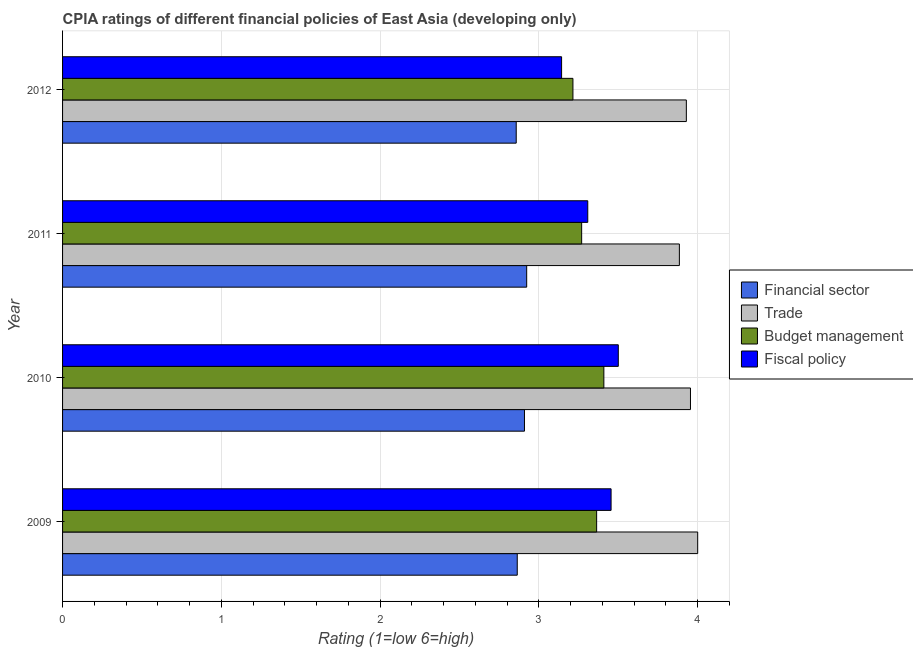How many different coloured bars are there?
Offer a very short reply. 4. Are the number of bars per tick equal to the number of legend labels?
Your response must be concise. Yes. Are the number of bars on each tick of the Y-axis equal?
Your answer should be very brief. Yes. How many bars are there on the 1st tick from the top?
Your answer should be very brief. 4. How many bars are there on the 2nd tick from the bottom?
Your answer should be compact. 4. Across all years, what is the maximum cpia rating of fiscal policy?
Give a very brief answer. 3.5. Across all years, what is the minimum cpia rating of fiscal policy?
Keep it short and to the point. 3.14. In which year was the cpia rating of budget management maximum?
Your answer should be very brief. 2010. What is the total cpia rating of fiscal policy in the graph?
Your answer should be very brief. 13.41. What is the difference between the cpia rating of financial sector in 2010 and that in 2012?
Provide a short and direct response. 0.05. What is the difference between the cpia rating of financial sector in 2009 and the cpia rating of fiscal policy in 2010?
Your answer should be very brief. -0.64. What is the average cpia rating of budget management per year?
Your answer should be very brief. 3.31. In the year 2009, what is the difference between the cpia rating of fiscal policy and cpia rating of budget management?
Your answer should be very brief. 0.09. In how many years, is the cpia rating of budget management greater than 3.6 ?
Your answer should be very brief. 0. What is the ratio of the cpia rating of financial sector in 2010 to that in 2011?
Give a very brief answer. 0.99. What is the difference between the highest and the second highest cpia rating of financial sector?
Provide a succinct answer. 0.01. What is the difference between the highest and the lowest cpia rating of budget management?
Keep it short and to the point. 0.19. Is the sum of the cpia rating of fiscal policy in 2009 and 2010 greater than the maximum cpia rating of financial sector across all years?
Make the answer very short. Yes. What does the 4th bar from the top in 2011 represents?
Provide a succinct answer. Financial sector. What does the 4th bar from the bottom in 2009 represents?
Give a very brief answer. Fiscal policy. How many bars are there?
Make the answer very short. 16. Are all the bars in the graph horizontal?
Offer a very short reply. Yes. How many years are there in the graph?
Your answer should be compact. 4. What is the difference between two consecutive major ticks on the X-axis?
Your answer should be compact. 1. Where does the legend appear in the graph?
Your answer should be very brief. Center right. What is the title of the graph?
Keep it short and to the point. CPIA ratings of different financial policies of East Asia (developing only). What is the label or title of the X-axis?
Your answer should be very brief. Rating (1=low 6=high). What is the Rating (1=low 6=high) in Financial sector in 2009?
Your answer should be very brief. 2.86. What is the Rating (1=low 6=high) in Budget management in 2009?
Provide a succinct answer. 3.36. What is the Rating (1=low 6=high) of Fiscal policy in 2009?
Make the answer very short. 3.45. What is the Rating (1=low 6=high) in Financial sector in 2010?
Offer a very short reply. 2.91. What is the Rating (1=low 6=high) of Trade in 2010?
Ensure brevity in your answer.  3.95. What is the Rating (1=low 6=high) of Budget management in 2010?
Offer a terse response. 3.41. What is the Rating (1=low 6=high) in Fiscal policy in 2010?
Provide a short and direct response. 3.5. What is the Rating (1=low 6=high) in Financial sector in 2011?
Provide a succinct answer. 2.92. What is the Rating (1=low 6=high) of Trade in 2011?
Ensure brevity in your answer.  3.88. What is the Rating (1=low 6=high) of Budget management in 2011?
Ensure brevity in your answer.  3.27. What is the Rating (1=low 6=high) in Fiscal policy in 2011?
Give a very brief answer. 3.31. What is the Rating (1=low 6=high) of Financial sector in 2012?
Your response must be concise. 2.86. What is the Rating (1=low 6=high) of Trade in 2012?
Make the answer very short. 3.93. What is the Rating (1=low 6=high) of Budget management in 2012?
Provide a short and direct response. 3.21. What is the Rating (1=low 6=high) in Fiscal policy in 2012?
Provide a short and direct response. 3.14. Across all years, what is the maximum Rating (1=low 6=high) of Financial sector?
Your answer should be compact. 2.92. Across all years, what is the maximum Rating (1=low 6=high) in Trade?
Offer a very short reply. 4. Across all years, what is the maximum Rating (1=low 6=high) of Budget management?
Your answer should be very brief. 3.41. Across all years, what is the maximum Rating (1=low 6=high) of Fiscal policy?
Offer a terse response. 3.5. Across all years, what is the minimum Rating (1=low 6=high) of Financial sector?
Your response must be concise. 2.86. Across all years, what is the minimum Rating (1=low 6=high) in Trade?
Provide a succinct answer. 3.88. Across all years, what is the minimum Rating (1=low 6=high) of Budget management?
Your response must be concise. 3.21. Across all years, what is the minimum Rating (1=low 6=high) of Fiscal policy?
Provide a short and direct response. 3.14. What is the total Rating (1=low 6=high) of Financial sector in the graph?
Make the answer very short. 11.55. What is the total Rating (1=low 6=high) of Trade in the graph?
Your response must be concise. 15.77. What is the total Rating (1=low 6=high) of Budget management in the graph?
Keep it short and to the point. 13.26. What is the total Rating (1=low 6=high) of Fiscal policy in the graph?
Make the answer very short. 13.41. What is the difference between the Rating (1=low 6=high) of Financial sector in 2009 and that in 2010?
Give a very brief answer. -0.05. What is the difference between the Rating (1=low 6=high) of Trade in 2009 and that in 2010?
Offer a terse response. 0.05. What is the difference between the Rating (1=low 6=high) in Budget management in 2009 and that in 2010?
Provide a short and direct response. -0.05. What is the difference between the Rating (1=low 6=high) in Fiscal policy in 2009 and that in 2010?
Your answer should be very brief. -0.05. What is the difference between the Rating (1=low 6=high) in Financial sector in 2009 and that in 2011?
Offer a very short reply. -0.06. What is the difference between the Rating (1=low 6=high) in Trade in 2009 and that in 2011?
Your response must be concise. 0.12. What is the difference between the Rating (1=low 6=high) in Budget management in 2009 and that in 2011?
Provide a short and direct response. 0.09. What is the difference between the Rating (1=low 6=high) in Fiscal policy in 2009 and that in 2011?
Your response must be concise. 0.15. What is the difference between the Rating (1=low 6=high) in Financial sector in 2009 and that in 2012?
Your answer should be very brief. 0.01. What is the difference between the Rating (1=low 6=high) in Trade in 2009 and that in 2012?
Ensure brevity in your answer.  0.07. What is the difference between the Rating (1=low 6=high) of Budget management in 2009 and that in 2012?
Your answer should be compact. 0.15. What is the difference between the Rating (1=low 6=high) of Fiscal policy in 2009 and that in 2012?
Your response must be concise. 0.31. What is the difference between the Rating (1=low 6=high) of Financial sector in 2010 and that in 2011?
Offer a terse response. -0.01. What is the difference between the Rating (1=low 6=high) in Trade in 2010 and that in 2011?
Ensure brevity in your answer.  0.07. What is the difference between the Rating (1=low 6=high) in Budget management in 2010 and that in 2011?
Ensure brevity in your answer.  0.14. What is the difference between the Rating (1=low 6=high) in Fiscal policy in 2010 and that in 2011?
Ensure brevity in your answer.  0.19. What is the difference between the Rating (1=low 6=high) of Financial sector in 2010 and that in 2012?
Offer a terse response. 0.05. What is the difference between the Rating (1=low 6=high) of Trade in 2010 and that in 2012?
Provide a short and direct response. 0.03. What is the difference between the Rating (1=low 6=high) in Budget management in 2010 and that in 2012?
Provide a succinct answer. 0.19. What is the difference between the Rating (1=low 6=high) in Fiscal policy in 2010 and that in 2012?
Offer a terse response. 0.36. What is the difference between the Rating (1=low 6=high) of Financial sector in 2011 and that in 2012?
Your response must be concise. 0.07. What is the difference between the Rating (1=low 6=high) of Trade in 2011 and that in 2012?
Offer a terse response. -0.04. What is the difference between the Rating (1=low 6=high) in Budget management in 2011 and that in 2012?
Offer a terse response. 0.05. What is the difference between the Rating (1=low 6=high) of Fiscal policy in 2011 and that in 2012?
Give a very brief answer. 0.16. What is the difference between the Rating (1=low 6=high) in Financial sector in 2009 and the Rating (1=low 6=high) in Trade in 2010?
Your response must be concise. -1.09. What is the difference between the Rating (1=low 6=high) of Financial sector in 2009 and the Rating (1=low 6=high) of Budget management in 2010?
Your answer should be compact. -0.55. What is the difference between the Rating (1=low 6=high) in Financial sector in 2009 and the Rating (1=low 6=high) in Fiscal policy in 2010?
Make the answer very short. -0.64. What is the difference between the Rating (1=low 6=high) of Trade in 2009 and the Rating (1=low 6=high) of Budget management in 2010?
Provide a succinct answer. 0.59. What is the difference between the Rating (1=low 6=high) of Trade in 2009 and the Rating (1=low 6=high) of Fiscal policy in 2010?
Ensure brevity in your answer.  0.5. What is the difference between the Rating (1=low 6=high) of Budget management in 2009 and the Rating (1=low 6=high) of Fiscal policy in 2010?
Offer a terse response. -0.14. What is the difference between the Rating (1=low 6=high) in Financial sector in 2009 and the Rating (1=low 6=high) in Trade in 2011?
Your answer should be very brief. -1.02. What is the difference between the Rating (1=low 6=high) of Financial sector in 2009 and the Rating (1=low 6=high) of Budget management in 2011?
Ensure brevity in your answer.  -0.41. What is the difference between the Rating (1=low 6=high) of Financial sector in 2009 and the Rating (1=low 6=high) of Fiscal policy in 2011?
Keep it short and to the point. -0.44. What is the difference between the Rating (1=low 6=high) in Trade in 2009 and the Rating (1=low 6=high) in Budget management in 2011?
Your answer should be compact. 0.73. What is the difference between the Rating (1=low 6=high) of Trade in 2009 and the Rating (1=low 6=high) of Fiscal policy in 2011?
Your answer should be compact. 0.69. What is the difference between the Rating (1=low 6=high) in Budget management in 2009 and the Rating (1=low 6=high) in Fiscal policy in 2011?
Your answer should be very brief. 0.06. What is the difference between the Rating (1=low 6=high) in Financial sector in 2009 and the Rating (1=low 6=high) in Trade in 2012?
Your response must be concise. -1.06. What is the difference between the Rating (1=low 6=high) in Financial sector in 2009 and the Rating (1=low 6=high) in Budget management in 2012?
Offer a terse response. -0.35. What is the difference between the Rating (1=low 6=high) in Financial sector in 2009 and the Rating (1=low 6=high) in Fiscal policy in 2012?
Keep it short and to the point. -0.28. What is the difference between the Rating (1=low 6=high) in Trade in 2009 and the Rating (1=low 6=high) in Budget management in 2012?
Provide a short and direct response. 0.79. What is the difference between the Rating (1=low 6=high) in Budget management in 2009 and the Rating (1=low 6=high) in Fiscal policy in 2012?
Provide a short and direct response. 0.22. What is the difference between the Rating (1=low 6=high) of Financial sector in 2010 and the Rating (1=low 6=high) of Trade in 2011?
Ensure brevity in your answer.  -0.98. What is the difference between the Rating (1=low 6=high) of Financial sector in 2010 and the Rating (1=low 6=high) of Budget management in 2011?
Provide a short and direct response. -0.36. What is the difference between the Rating (1=low 6=high) of Financial sector in 2010 and the Rating (1=low 6=high) of Fiscal policy in 2011?
Your answer should be very brief. -0.4. What is the difference between the Rating (1=low 6=high) in Trade in 2010 and the Rating (1=low 6=high) in Budget management in 2011?
Your answer should be very brief. 0.69. What is the difference between the Rating (1=low 6=high) in Trade in 2010 and the Rating (1=low 6=high) in Fiscal policy in 2011?
Provide a short and direct response. 0.65. What is the difference between the Rating (1=low 6=high) in Budget management in 2010 and the Rating (1=low 6=high) in Fiscal policy in 2011?
Ensure brevity in your answer.  0.1. What is the difference between the Rating (1=low 6=high) of Financial sector in 2010 and the Rating (1=low 6=high) of Trade in 2012?
Offer a terse response. -1.02. What is the difference between the Rating (1=low 6=high) of Financial sector in 2010 and the Rating (1=low 6=high) of Budget management in 2012?
Ensure brevity in your answer.  -0.31. What is the difference between the Rating (1=low 6=high) in Financial sector in 2010 and the Rating (1=low 6=high) in Fiscal policy in 2012?
Give a very brief answer. -0.23. What is the difference between the Rating (1=low 6=high) in Trade in 2010 and the Rating (1=low 6=high) in Budget management in 2012?
Make the answer very short. 0.74. What is the difference between the Rating (1=low 6=high) in Trade in 2010 and the Rating (1=low 6=high) in Fiscal policy in 2012?
Give a very brief answer. 0.81. What is the difference between the Rating (1=low 6=high) in Budget management in 2010 and the Rating (1=low 6=high) in Fiscal policy in 2012?
Offer a terse response. 0.27. What is the difference between the Rating (1=low 6=high) of Financial sector in 2011 and the Rating (1=low 6=high) of Trade in 2012?
Provide a short and direct response. -1.01. What is the difference between the Rating (1=low 6=high) of Financial sector in 2011 and the Rating (1=low 6=high) of Budget management in 2012?
Offer a very short reply. -0.29. What is the difference between the Rating (1=low 6=high) in Financial sector in 2011 and the Rating (1=low 6=high) in Fiscal policy in 2012?
Your answer should be very brief. -0.22. What is the difference between the Rating (1=low 6=high) of Trade in 2011 and the Rating (1=low 6=high) of Budget management in 2012?
Keep it short and to the point. 0.67. What is the difference between the Rating (1=low 6=high) in Trade in 2011 and the Rating (1=low 6=high) in Fiscal policy in 2012?
Provide a succinct answer. 0.74. What is the difference between the Rating (1=low 6=high) of Budget management in 2011 and the Rating (1=low 6=high) of Fiscal policy in 2012?
Your answer should be compact. 0.13. What is the average Rating (1=low 6=high) in Financial sector per year?
Keep it short and to the point. 2.89. What is the average Rating (1=low 6=high) of Trade per year?
Your answer should be very brief. 3.94. What is the average Rating (1=low 6=high) in Budget management per year?
Offer a very short reply. 3.31. What is the average Rating (1=low 6=high) of Fiscal policy per year?
Your response must be concise. 3.35. In the year 2009, what is the difference between the Rating (1=low 6=high) of Financial sector and Rating (1=low 6=high) of Trade?
Keep it short and to the point. -1.14. In the year 2009, what is the difference between the Rating (1=low 6=high) in Financial sector and Rating (1=low 6=high) in Fiscal policy?
Provide a short and direct response. -0.59. In the year 2009, what is the difference between the Rating (1=low 6=high) in Trade and Rating (1=low 6=high) in Budget management?
Offer a terse response. 0.64. In the year 2009, what is the difference between the Rating (1=low 6=high) in Trade and Rating (1=low 6=high) in Fiscal policy?
Make the answer very short. 0.55. In the year 2009, what is the difference between the Rating (1=low 6=high) of Budget management and Rating (1=low 6=high) of Fiscal policy?
Offer a very short reply. -0.09. In the year 2010, what is the difference between the Rating (1=low 6=high) in Financial sector and Rating (1=low 6=high) in Trade?
Your response must be concise. -1.05. In the year 2010, what is the difference between the Rating (1=low 6=high) in Financial sector and Rating (1=low 6=high) in Fiscal policy?
Ensure brevity in your answer.  -0.59. In the year 2010, what is the difference between the Rating (1=low 6=high) of Trade and Rating (1=low 6=high) of Budget management?
Your answer should be very brief. 0.55. In the year 2010, what is the difference between the Rating (1=low 6=high) in Trade and Rating (1=low 6=high) in Fiscal policy?
Your answer should be very brief. 0.45. In the year 2010, what is the difference between the Rating (1=low 6=high) in Budget management and Rating (1=low 6=high) in Fiscal policy?
Your response must be concise. -0.09. In the year 2011, what is the difference between the Rating (1=low 6=high) of Financial sector and Rating (1=low 6=high) of Trade?
Provide a succinct answer. -0.96. In the year 2011, what is the difference between the Rating (1=low 6=high) of Financial sector and Rating (1=low 6=high) of Budget management?
Keep it short and to the point. -0.35. In the year 2011, what is the difference between the Rating (1=low 6=high) of Financial sector and Rating (1=low 6=high) of Fiscal policy?
Offer a very short reply. -0.38. In the year 2011, what is the difference between the Rating (1=low 6=high) in Trade and Rating (1=low 6=high) in Budget management?
Offer a very short reply. 0.62. In the year 2011, what is the difference between the Rating (1=low 6=high) of Trade and Rating (1=low 6=high) of Fiscal policy?
Your answer should be compact. 0.58. In the year 2011, what is the difference between the Rating (1=low 6=high) in Budget management and Rating (1=low 6=high) in Fiscal policy?
Offer a terse response. -0.04. In the year 2012, what is the difference between the Rating (1=low 6=high) in Financial sector and Rating (1=low 6=high) in Trade?
Provide a short and direct response. -1.07. In the year 2012, what is the difference between the Rating (1=low 6=high) in Financial sector and Rating (1=low 6=high) in Budget management?
Make the answer very short. -0.36. In the year 2012, what is the difference between the Rating (1=low 6=high) in Financial sector and Rating (1=low 6=high) in Fiscal policy?
Give a very brief answer. -0.29. In the year 2012, what is the difference between the Rating (1=low 6=high) of Trade and Rating (1=low 6=high) of Fiscal policy?
Make the answer very short. 0.79. In the year 2012, what is the difference between the Rating (1=low 6=high) of Budget management and Rating (1=low 6=high) of Fiscal policy?
Provide a short and direct response. 0.07. What is the ratio of the Rating (1=low 6=high) in Financial sector in 2009 to that in 2010?
Your answer should be compact. 0.98. What is the ratio of the Rating (1=low 6=high) of Trade in 2009 to that in 2010?
Your answer should be very brief. 1.01. What is the ratio of the Rating (1=low 6=high) in Budget management in 2009 to that in 2010?
Provide a succinct answer. 0.99. What is the ratio of the Rating (1=low 6=high) of Financial sector in 2009 to that in 2011?
Offer a terse response. 0.98. What is the ratio of the Rating (1=low 6=high) in Trade in 2009 to that in 2011?
Your response must be concise. 1.03. What is the ratio of the Rating (1=low 6=high) of Budget management in 2009 to that in 2011?
Keep it short and to the point. 1.03. What is the ratio of the Rating (1=low 6=high) of Fiscal policy in 2009 to that in 2011?
Ensure brevity in your answer.  1.04. What is the ratio of the Rating (1=low 6=high) in Financial sector in 2009 to that in 2012?
Ensure brevity in your answer.  1. What is the ratio of the Rating (1=low 6=high) in Trade in 2009 to that in 2012?
Your answer should be very brief. 1.02. What is the ratio of the Rating (1=low 6=high) in Budget management in 2009 to that in 2012?
Ensure brevity in your answer.  1.05. What is the ratio of the Rating (1=low 6=high) in Fiscal policy in 2009 to that in 2012?
Make the answer very short. 1.1. What is the ratio of the Rating (1=low 6=high) of Financial sector in 2010 to that in 2011?
Your answer should be very brief. 1. What is the ratio of the Rating (1=low 6=high) in Trade in 2010 to that in 2011?
Your answer should be compact. 1.02. What is the ratio of the Rating (1=low 6=high) of Budget management in 2010 to that in 2011?
Ensure brevity in your answer.  1.04. What is the ratio of the Rating (1=low 6=high) in Fiscal policy in 2010 to that in 2011?
Ensure brevity in your answer.  1.06. What is the ratio of the Rating (1=low 6=high) in Financial sector in 2010 to that in 2012?
Provide a succinct answer. 1.02. What is the ratio of the Rating (1=low 6=high) in Trade in 2010 to that in 2012?
Ensure brevity in your answer.  1.01. What is the ratio of the Rating (1=low 6=high) in Budget management in 2010 to that in 2012?
Offer a very short reply. 1.06. What is the ratio of the Rating (1=low 6=high) in Fiscal policy in 2010 to that in 2012?
Offer a terse response. 1.11. What is the ratio of the Rating (1=low 6=high) in Financial sector in 2011 to that in 2012?
Provide a succinct answer. 1.02. What is the ratio of the Rating (1=low 6=high) of Trade in 2011 to that in 2012?
Provide a succinct answer. 0.99. What is the ratio of the Rating (1=low 6=high) of Budget management in 2011 to that in 2012?
Your answer should be very brief. 1.02. What is the ratio of the Rating (1=low 6=high) of Fiscal policy in 2011 to that in 2012?
Give a very brief answer. 1.05. What is the difference between the highest and the second highest Rating (1=low 6=high) in Financial sector?
Offer a very short reply. 0.01. What is the difference between the highest and the second highest Rating (1=low 6=high) in Trade?
Keep it short and to the point. 0.05. What is the difference between the highest and the second highest Rating (1=low 6=high) of Budget management?
Give a very brief answer. 0.05. What is the difference between the highest and the second highest Rating (1=low 6=high) of Fiscal policy?
Your answer should be very brief. 0.05. What is the difference between the highest and the lowest Rating (1=low 6=high) in Financial sector?
Your response must be concise. 0.07. What is the difference between the highest and the lowest Rating (1=low 6=high) in Trade?
Provide a succinct answer. 0.12. What is the difference between the highest and the lowest Rating (1=low 6=high) in Budget management?
Keep it short and to the point. 0.19. What is the difference between the highest and the lowest Rating (1=low 6=high) in Fiscal policy?
Provide a succinct answer. 0.36. 